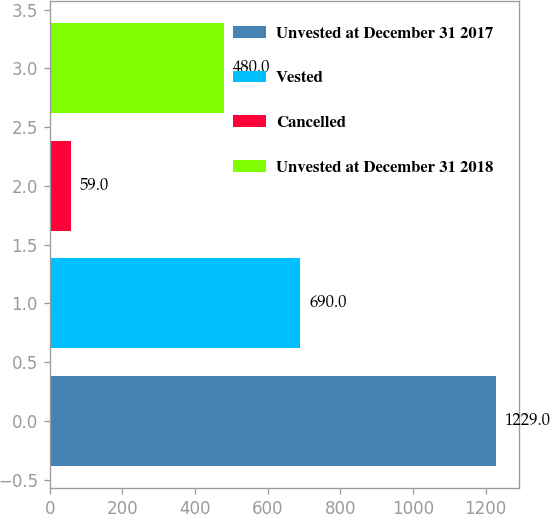<chart> <loc_0><loc_0><loc_500><loc_500><bar_chart><fcel>Unvested at December 31 2017<fcel>Vested<fcel>Cancelled<fcel>Unvested at December 31 2018<nl><fcel>1229<fcel>690<fcel>59<fcel>480<nl></chart> 